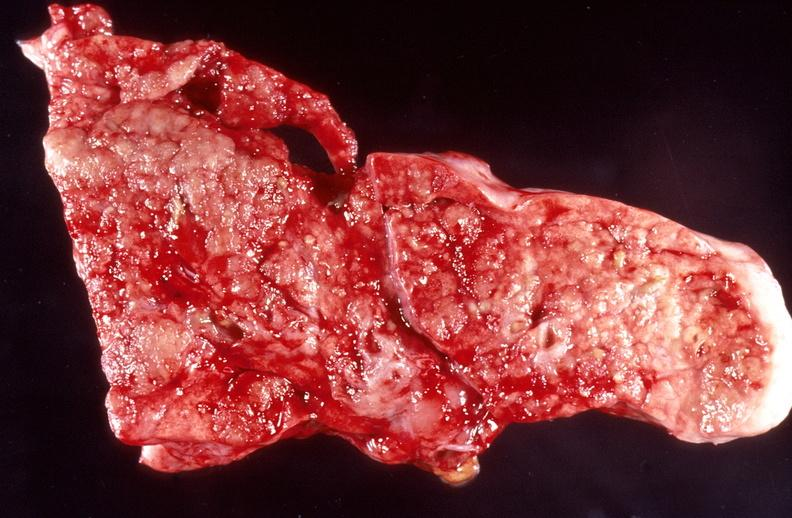what is present?
Answer the question using a single word or phrase. Respiratory 